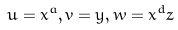Convert formula to latex. <formula><loc_0><loc_0><loc_500><loc_500>u = x ^ { a } , v = y , w = x ^ { d } z</formula> 